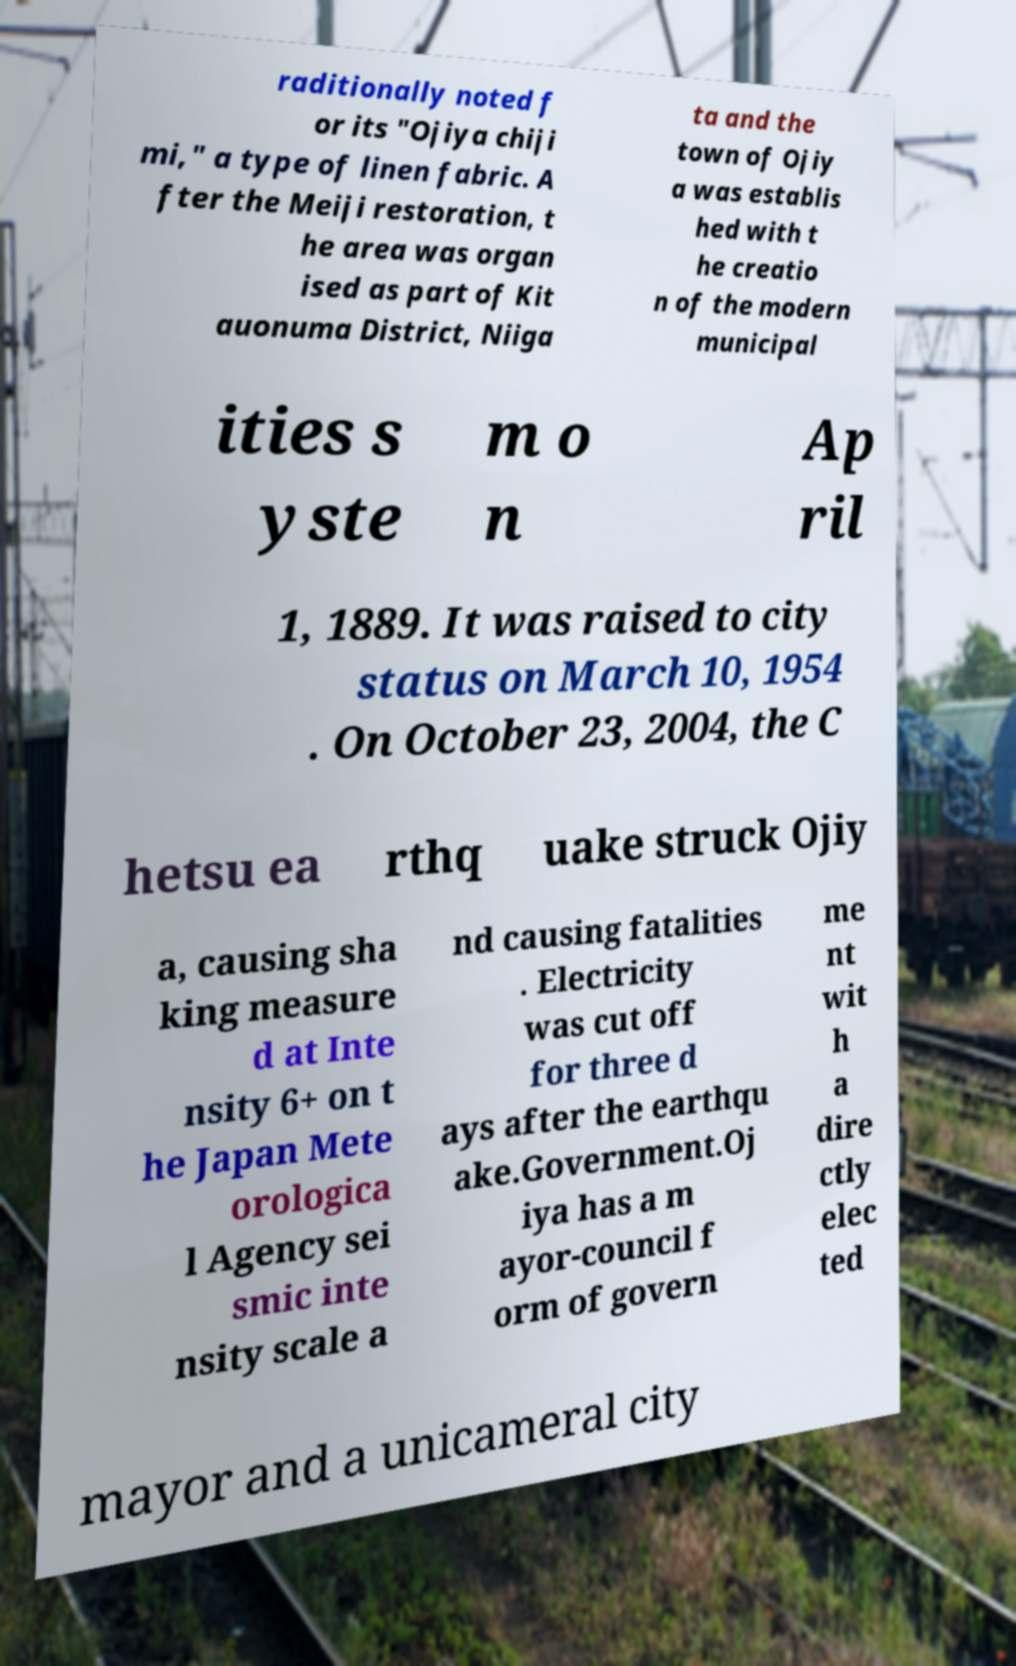Could you assist in decoding the text presented in this image and type it out clearly? raditionally noted f or its "Ojiya chiji mi," a type of linen fabric. A fter the Meiji restoration, t he area was organ ised as part of Kit auonuma District, Niiga ta and the town of Ojiy a was establis hed with t he creatio n of the modern municipal ities s yste m o n Ap ril 1, 1889. It was raised to city status on March 10, 1954 . On October 23, 2004, the C hetsu ea rthq uake struck Ojiy a, causing sha king measure d at Inte nsity 6+ on t he Japan Mete orologica l Agency sei smic inte nsity scale a nd causing fatalities . Electricity was cut off for three d ays after the earthqu ake.Government.Oj iya has a m ayor-council f orm of govern me nt wit h a dire ctly elec ted mayor and a unicameral city 